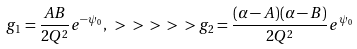Convert formula to latex. <formula><loc_0><loc_0><loc_500><loc_500>g _ { 1 } = \frac { A B } { 2 Q ^ { 2 } } e ^ { - \psi _ { 0 } } , \ > \ > \ > \ > \ > g _ { 2 } = \frac { ( \alpha - A ) ( \alpha - B ) } { 2 Q ^ { 2 } } e ^ { \psi _ { 0 } }</formula> 